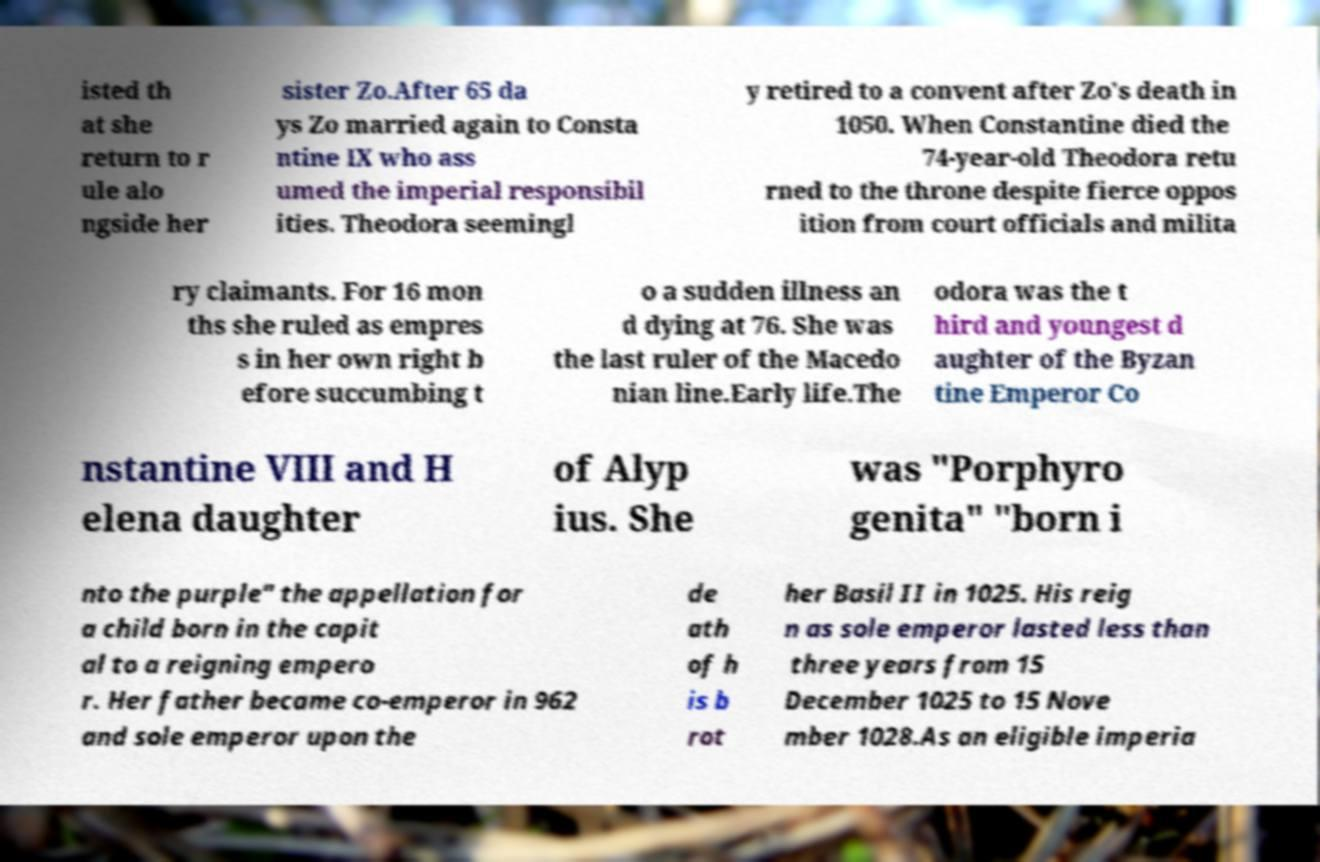Could you extract and type out the text from this image? isted th at she return to r ule alo ngside her sister Zo.After 65 da ys Zo married again to Consta ntine IX who ass umed the imperial responsibil ities. Theodora seemingl y retired to a convent after Zo's death in 1050. When Constantine died the 74-year-old Theodora retu rned to the throne despite fierce oppos ition from court officials and milita ry claimants. For 16 mon ths she ruled as empres s in her own right b efore succumbing t o a sudden illness an d dying at 76. She was the last ruler of the Macedo nian line.Early life.The odora was the t hird and youngest d aughter of the Byzan tine Emperor Co nstantine VIII and H elena daughter of Alyp ius. She was "Porphyro genita" "born i nto the purple" the appellation for a child born in the capit al to a reigning empero r. Her father became co-emperor in 962 and sole emperor upon the de ath of h is b rot her Basil II in 1025. His reig n as sole emperor lasted less than three years from 15 December 1025 to 15 Nove mber 1028.As an eligible imperia 